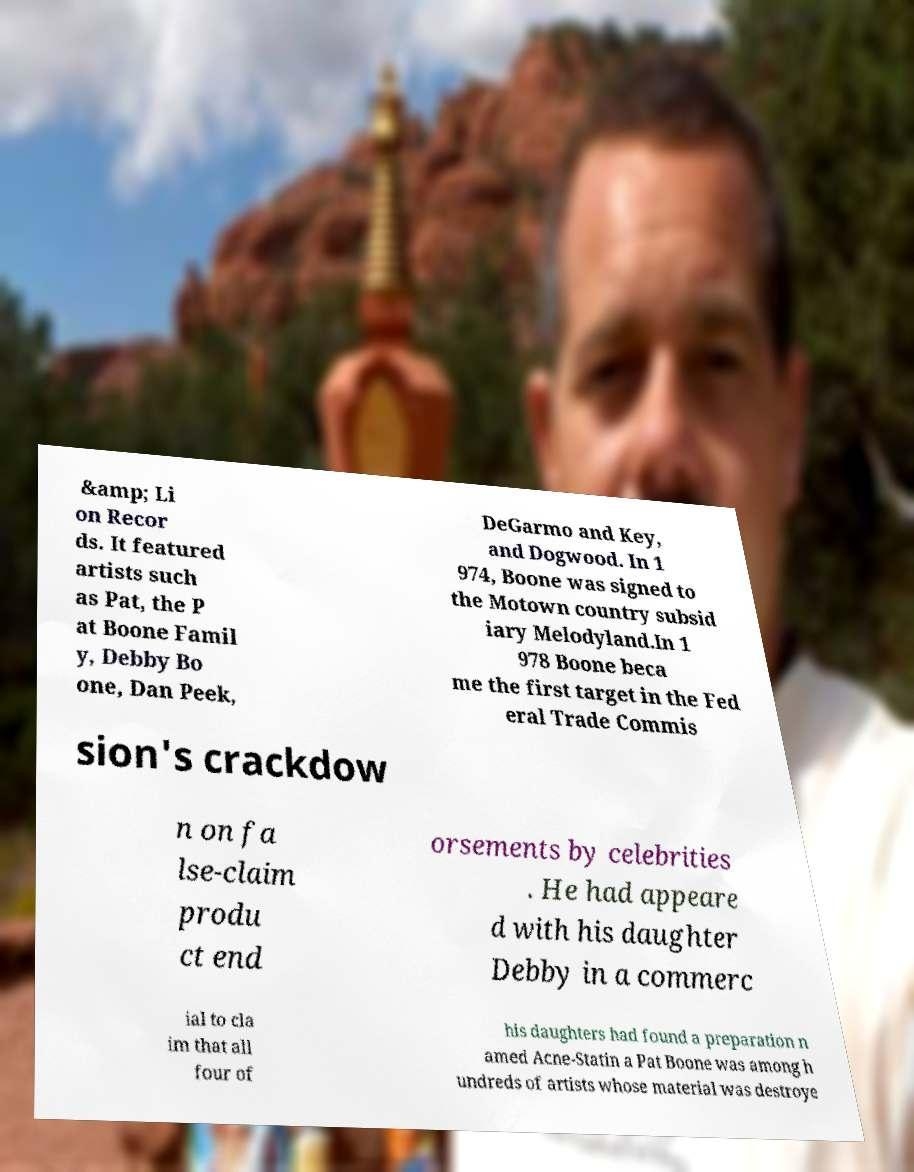There's text embedded in this image that I need extracted. Can you transcribe it verbatim? &amp; Li on Recor ds. It featured artists such as Pat, the P at Boone Famil y, Debby Bo one, Dan Peek, DeGarmo and Key, and Dogwood. In 1 974, Boone was signed to the Motown country subsid iary Melodyland.In 1 978 Boone beca me the first target in the Fed eral Trade Commis sion's crackdow n on fa lse-claim produ ct end orsements by celebrities . He had appeare d with his daughter Debby in a commerc ial to cla im that all four of his daughters had found a preparation n amed Acne-Statin a Pat Boone was among h undreds of artists whose material was destroye 